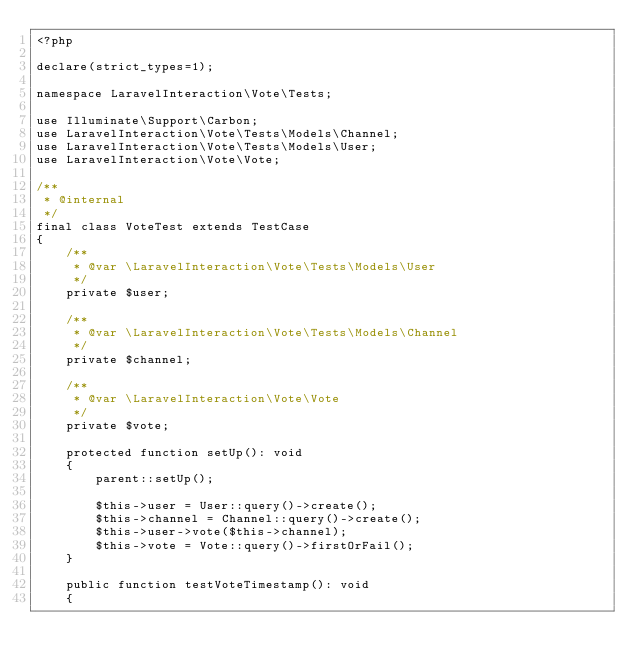<code> <loc_0><loc_0><loc_500><loc_500><_PHP_><?php

declare(strict_types=1);

namespace LaravelInteraction\Vote\Tests;

use Illuminate\Support\Carbon;
use LaravelInteraction\Vote\Tests\Models\Channel;
use LaravelInteraction\Vote\Tests\Models\User;
use LaravelInteraction\Vote\Vote;

/**
 * @internal
 */
final class VoteTest extends TestCase
{
    /**
     * @var \LaravelInteraction\Vote\Tests\Models\User
     */
    private $user;

    /**
     * @var \LaravelInteraction\Vote\Tests\Models\Channel
     */
    private $channel;

    /**
     * @var \LaravelInteraction\Vote\Vote
     */
    private $vote;

    protected function setUp(): void
    {
        parent::setUp();

        $this->user = User::query()->create();
        $this->channel = Channel::query()->create();
        $this->user->vote($this->channel);
        $this->vote = Vote::query()->firstOrFail();
    }

    public function testVoteTimestamp(): void
    {</code> 